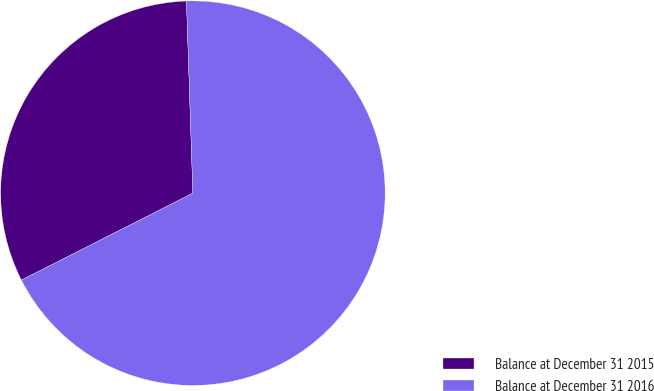Convert chart. <chart><loc_0><loc_0><loc_500><loc_500><pie_chart><fcel>Balance at December 31 2015<fcel>Balance at December 31 2016<nl><fcel>31.94%<fcel>68.06%<nl></chart> 